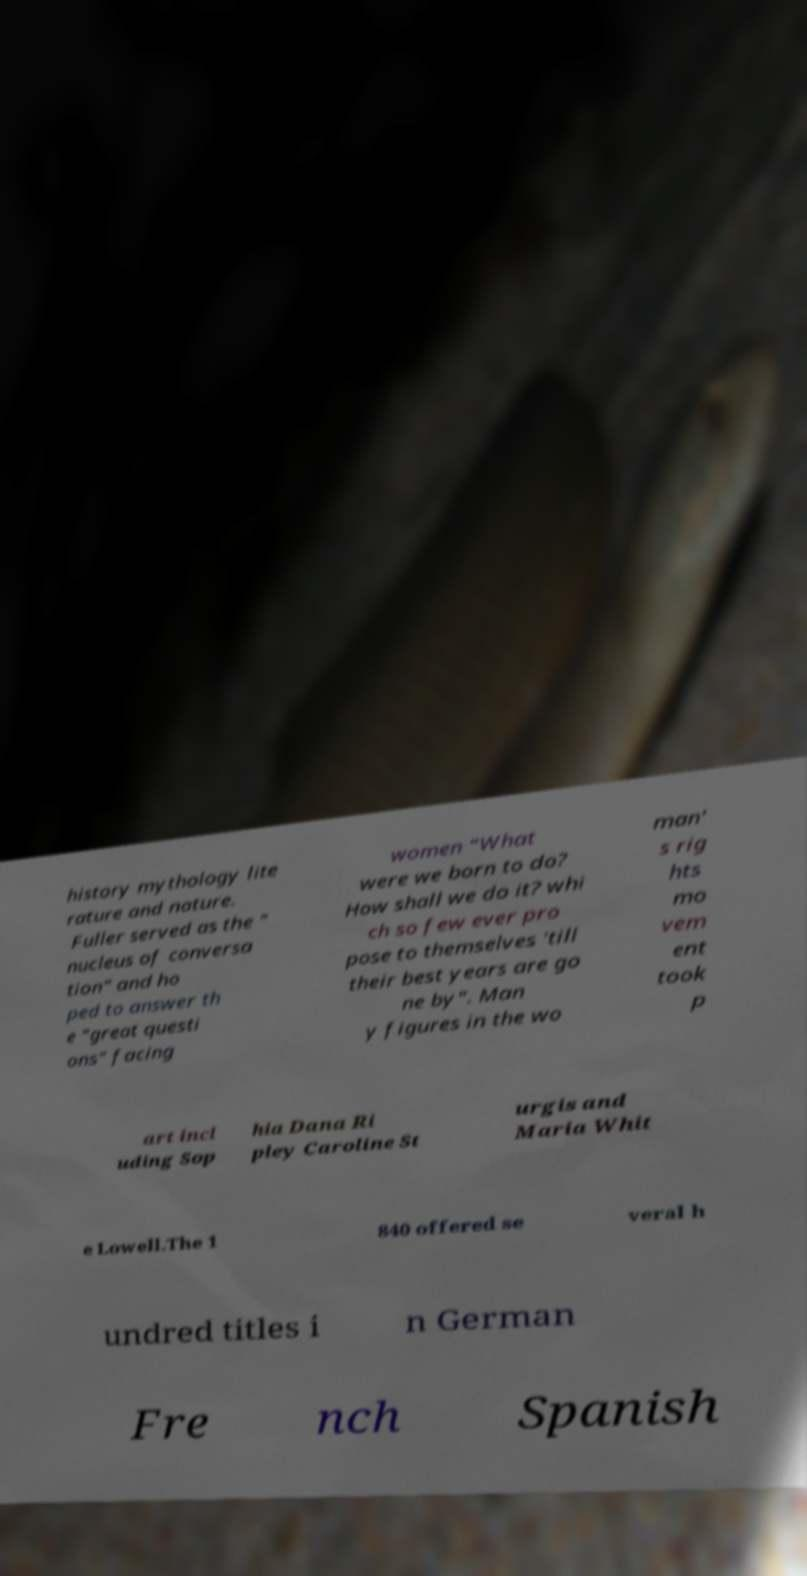For documentation purposes, I need the text within this image transcribed. Could you provide that? history mythology lite rature and nature. Fuller served as the " nucleus of conversa tion" and ho ped to answer th e "great questi ons" facing women "What were we born to do? How shall we do it? whi ch so few ever pro pose to themselves 'till their best years are go ne by". Man y figures in the wo man' s rig hts mo vem ent took p art incl uding Sop hia Dana Ri pley Caroline St urgis and Maria Whit e Lowell.The 1 840 offered se veral h undred titles i n German Fre nch Spanish 